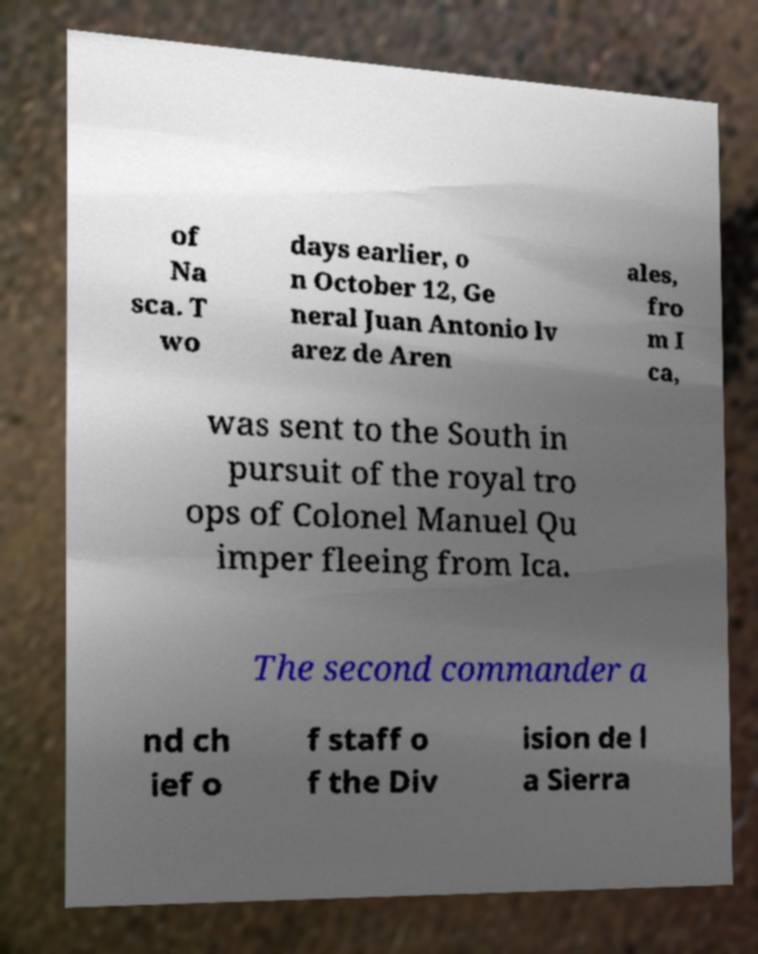Please identify and transcribe the text found in this image. of Na sca. T wo days earlier, o n October 12, Ge neral Juan Antonio lv arez de Aren ales, fro m I ca, was sent to the South in pursuit of the royal tro ops of Colonel Manuel Qu imper fleeing from Ica. The second commander a nd ch ief o f staff o f the Div ision de l a Sierra 